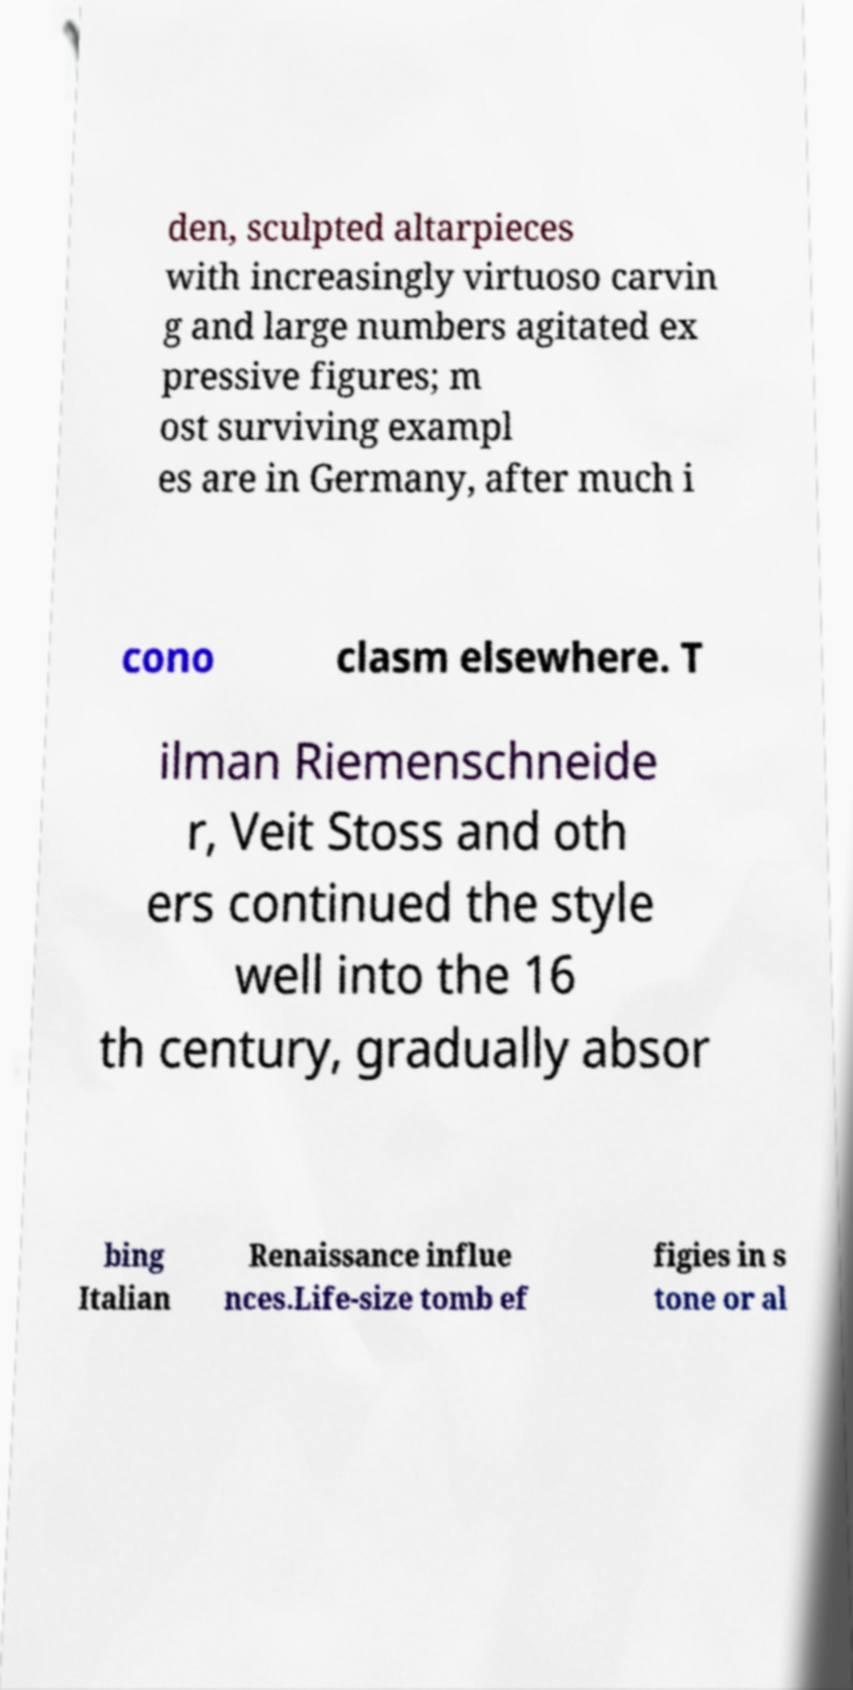There's text embedded in this image that I need extracted. Can you transcribe it verbatim? den, sculpted altarpieces with increasingly virtuoso carvin g and large numbers agitated ex pressive figures; m ost surviving exampl es are in Germany, after much i cono clasm elsewhere. T ilman Riemenschneide r, Veit Stoss and oth ers continued the style well into the 16 th century, gradually absor bing Italian Renaissance influe nces.Life-size tomb ef figies in s tone or al 